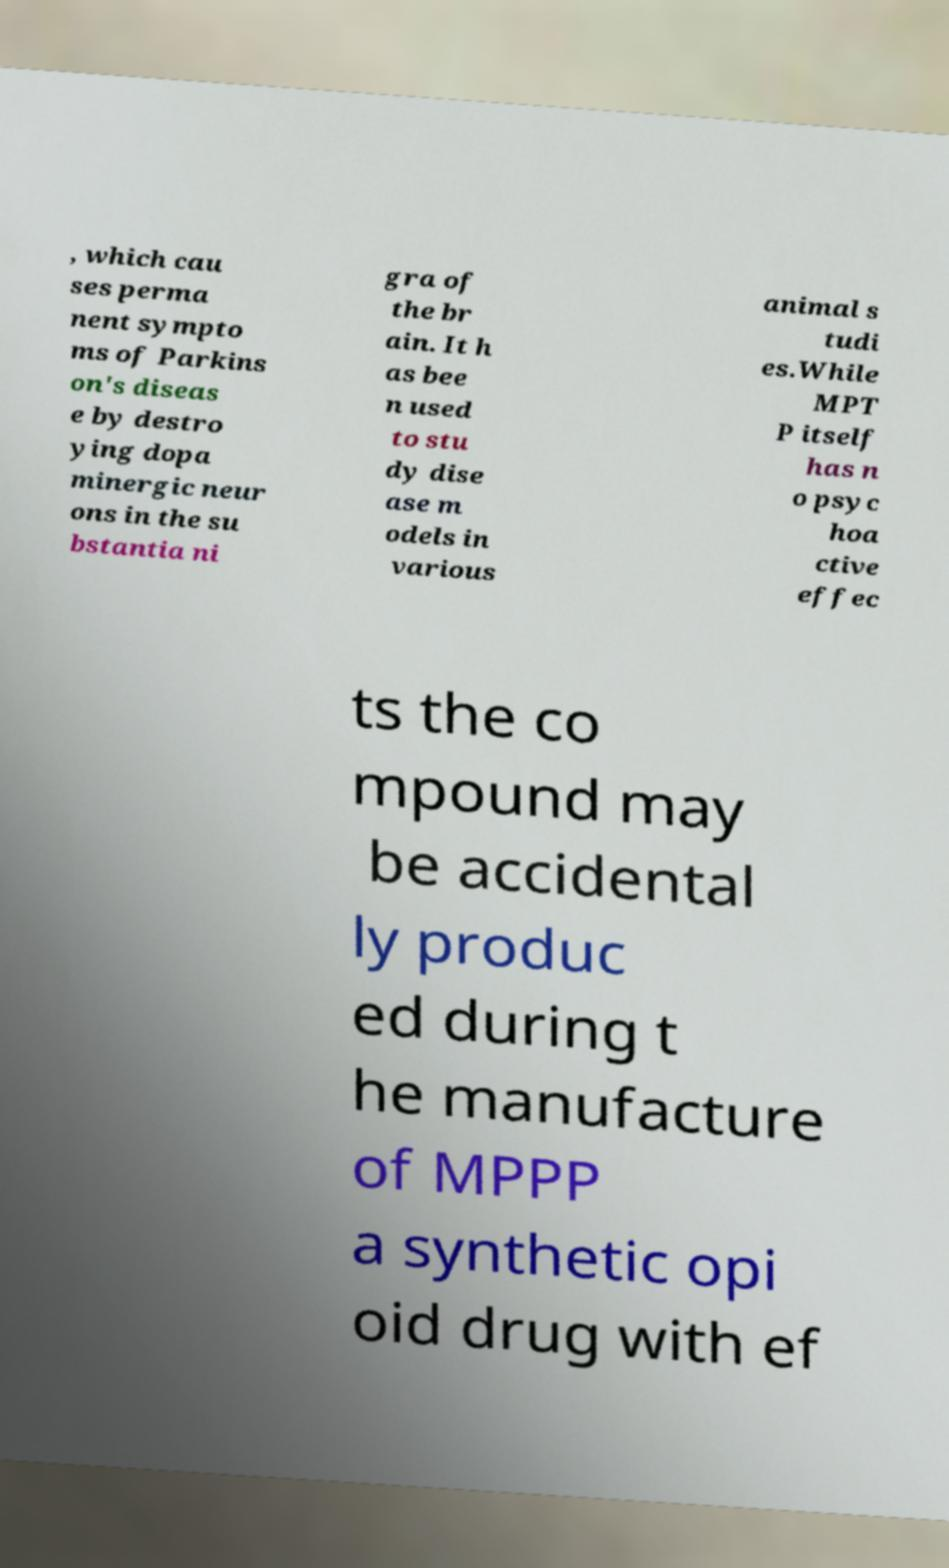I need the written content from this picture converted into text. Can you do that? , which cau ses perma nent sympto ms of Parkins on's diseas e by destro ying dopa minergic neur ons in the su bstantia ni gra of the br ain. It h as bee n used to stu dy dise ase m odels in various animal s tudi es.While MPT P itself has n o psyc hoa ctive effec ts the co mpound may be accidental ly produc ed during t he manufacture of MPPP a synthetic opi oid drug with ef 